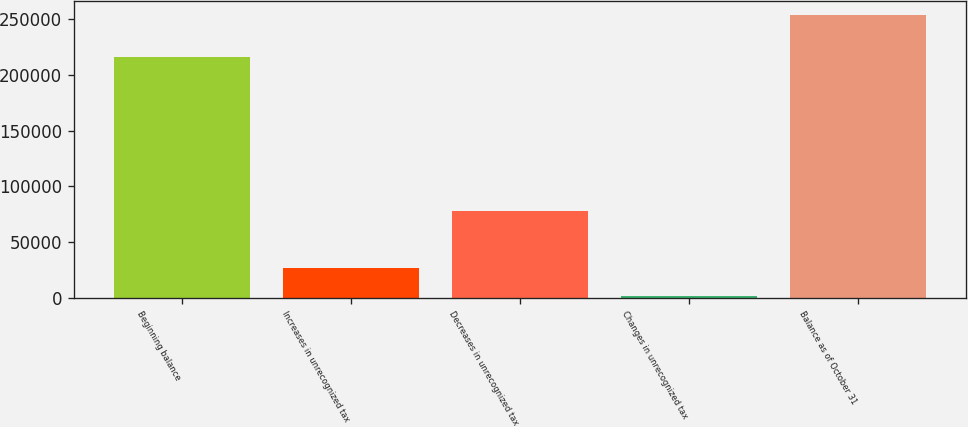Convert chart. <chart><loc_0><loc_0><loc_500><loc_500><bar_chart><fcel>Beginning balance<fcel>Increases in unrecognized tax<fcel>Decreases in unrecognized tax<fcel>Changes in unrecognized tax<fcel>Balance as of October 31<nl><fcel>216627<fcel>27205<fcel>77573<fcel>2021<fcel>253861<nl></chart> 